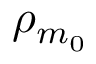Convert formula to latex. <formula><loc_0><loc_0><loc_500><loc_500>\rho _ { m _ { 0 } }</formula> 